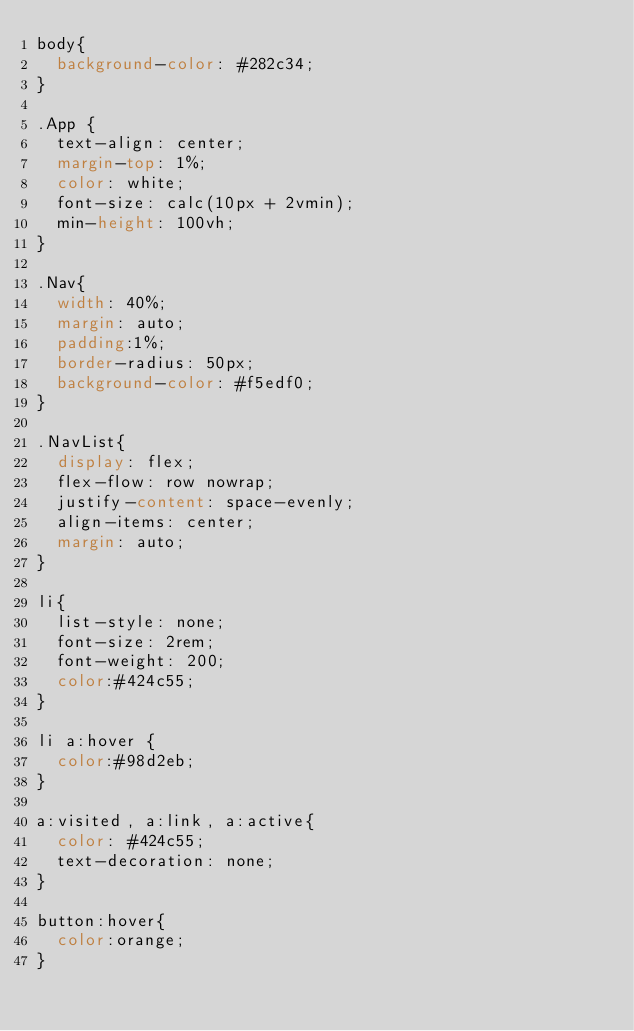Convert code to text. <code><loc_0><loc_0><loc_500><loc_500><_CSS_>body{
  background-color: #282c34;
}

.App {
  text-align: center;
  margin-top: 1%;
  color: white;
  font-size: calc(10px + 2vmin);
  min-height: 100vh;
}

.Nav{
  width: 40%;
  margin: auto;
  padding:1%;
  border-radius: 50px;
  background-color: #f5edf0;
}

.NavList{
  display: flex;
  flex-flow: row nowrap;
  justify-content: space-evenly;
  align-items: center;
  margin: auto;
}

li{
  list-style: none;
  font-size: 2rem;
  font-weight: 200;
  color:#424c55;
}

li a:hover {
  color:#98d2eb;
}

a:visited, a:link, a:active{
  color: #424c55;
  text-decoration: none;
}

button:hover{
  color:orange;
}</code> 